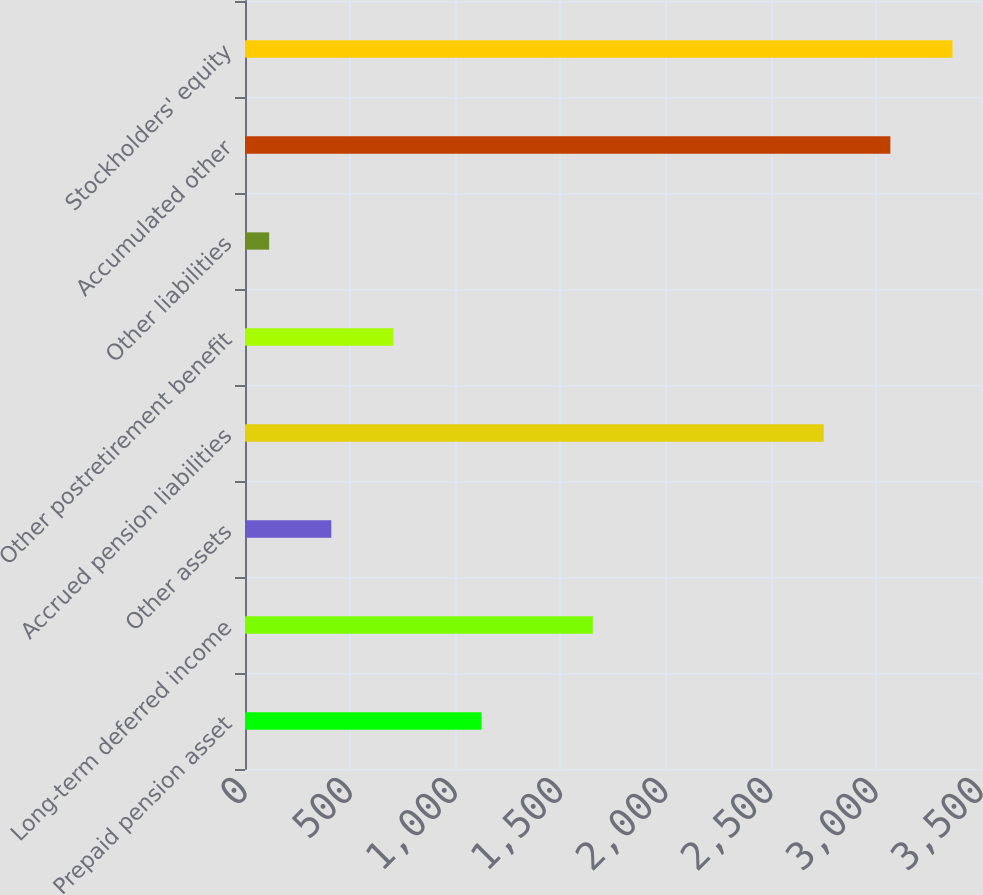Convert chart. <chart><loc_0><loc_0><loc_500><loc_500><bar_chart><fcel>Prepaid pension asset<fcel>Long-term deferred income<fcel>Other assets<fcel>Accrued pension liabilities<fcel>Other postretirement benefit<fcel>Other liabilities<fcel>Accumulated other<fcel>Stockholders' equity<nl><fcel>1125<fcel>1654<fcel>410.4<fcel>2752<fcel>705.8<fcel>115<fcel>3069<fcel>3364.4<nl></chart> 